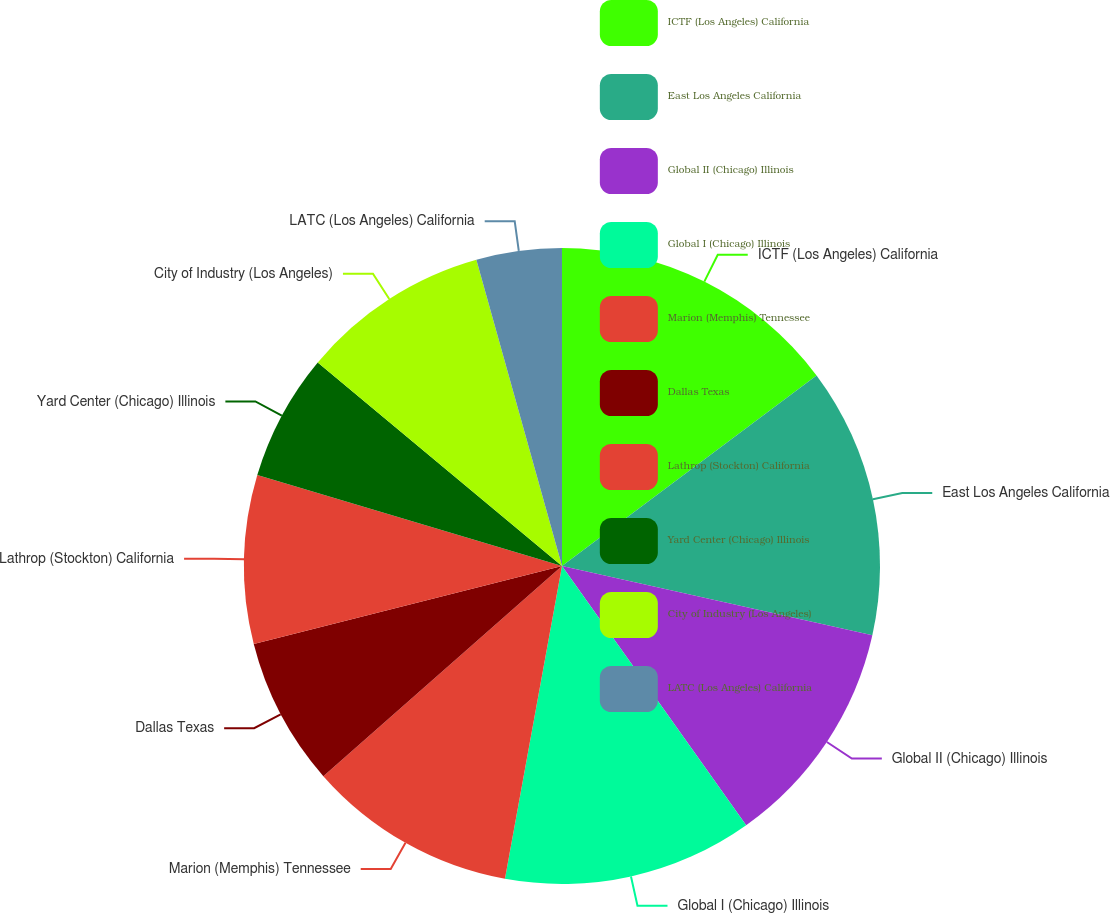<chart> <loc_0><loc_0><loc_500><loc_500><pie_chart><fcel>ICTF (Los Angeles) California<fcel>East Los Angeles California<fcel>Global II (Chicago) Illinois<fcel>Global I (Chicago) Illinois<fcel>Marion (Memphis) Tennessee<fcel>Dallas Texas<fcel>Lathrop (Stockton) California<fcel>Yard Center (Chicago) Illinois<fcel>City of Industry (Los Angeles)<fcel>LATC (Los Angeles) California<nl><fcel>14.77%<fcel>13.73%<fcel>11.67%<fcel>12.7%<fcel>10.64%<fcel>7.54%<fcel>8.57%<fcel>6.44%<fcel>9.6%<fcel>4.34%<nl></chart> 